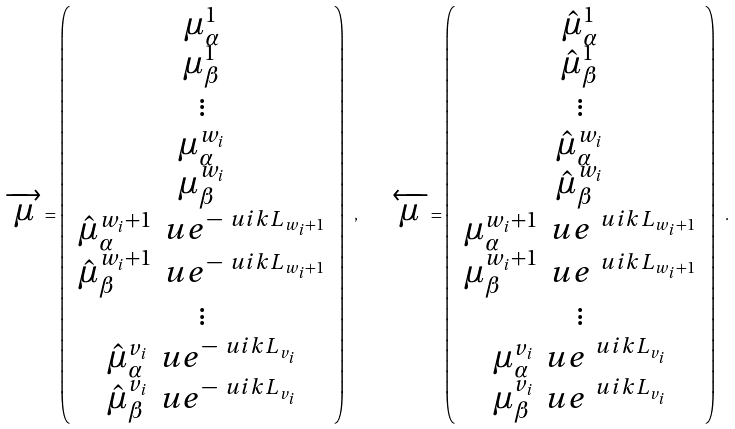<formula> <loc_0><loc_0><loc_500><loc_500>\overrightarrow { \mu } = \left ( \begin{array} { c } \mu ^ { 1 } _ { \alpha } \\ \mu ^ { 1 } _ { \beta } \\ \vdots \\ \mu ^ { w _ { i } } _ { \alpha } \\ \mu ^ { w _ { i } } _ { \beta } \\ \hat { \mu } ^ { w _ { i } + 1 } _ { \alpha } \, \ u e ^ { - \ u i k L _ { w _ { i } + 1 } } \\ \hat { \mu } ^ { w _ { i } + 1 } _ { \beta } \, \ u e ^ { - \ u i k L _ { w _ { i } + 1 } } \\ \vdots \\ \hat { \mu } ^ { v _ { i } } _ { \alpha } \, \ u e ^ { - \ u i k L _ { v _ { i } } } \\ \hat { \mu } ^ { v _ { i } } _ { \beta } \, \ u e ^ { - \ u i k L _ { v _ { i } } } \\ \end{array} \right ) \ , \quad \overleftarrow { \mu } = \left ( \begin{array} { c } \hat { \mu } ^ { 1 } _ { \alpha } \\ \hat { \mu } ^ { 1 } _ { \beta } \\ \vdots \\ \hat { \mu } ^ { w _ { i } } _ { \alpha } \\ \hat { \mu } ^ { w _ { i } } _ { \beta } \\ \mu ^ { w _ { i } + 1 } _ { \alpha } \, \ u e ^ { \ u i k L _ { w _ { i } + 1 } } \\ \mu ^ { w _ { i } + 1 } _ { \beta } \, \ u e ^ { \ u i k L _ { w _ { i } + 1 } } \\ \vdots \\ \mu ^ { v _ { i } } _ { \alpha } \, \ u e ^ { \ u i k L _ { v _ { i } } } \\ \mu ^ { v _ { i } } _ { \beta } \, \ u e ^ { \ u i k L _ { v _ { i } } } \\ \end{array} \right ) \ .</formula> 